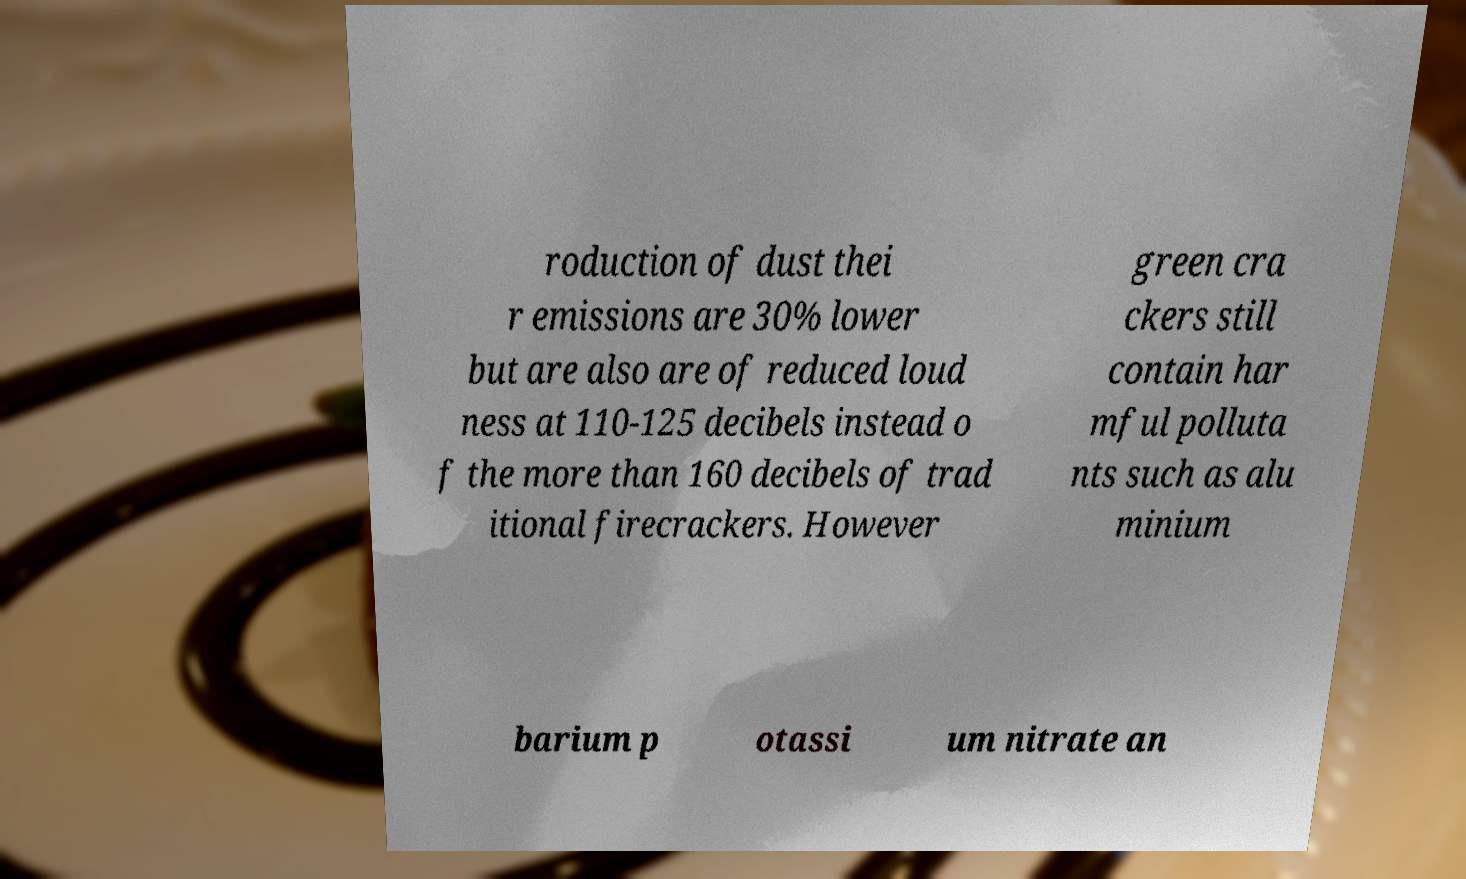For documentation purposes, I need the text within this image transcribed. Could you provide that? roduction of dust thei r emissions are 30% lower but are also are of reduced loud ness at 110-125 decibels instead o f the more than 160 decibels of trad itional firecrackers. However green cra ckers still contain har mful polluta nts such as alu minium barium p otassi um nitrate an 